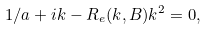Convert formula to latex. <formula><loc_0><loc_0><loc_500><loc_500>1 / a + i k - R _ { e } ( k , B ) k ^ { 2 } = 0 ,</formula> 